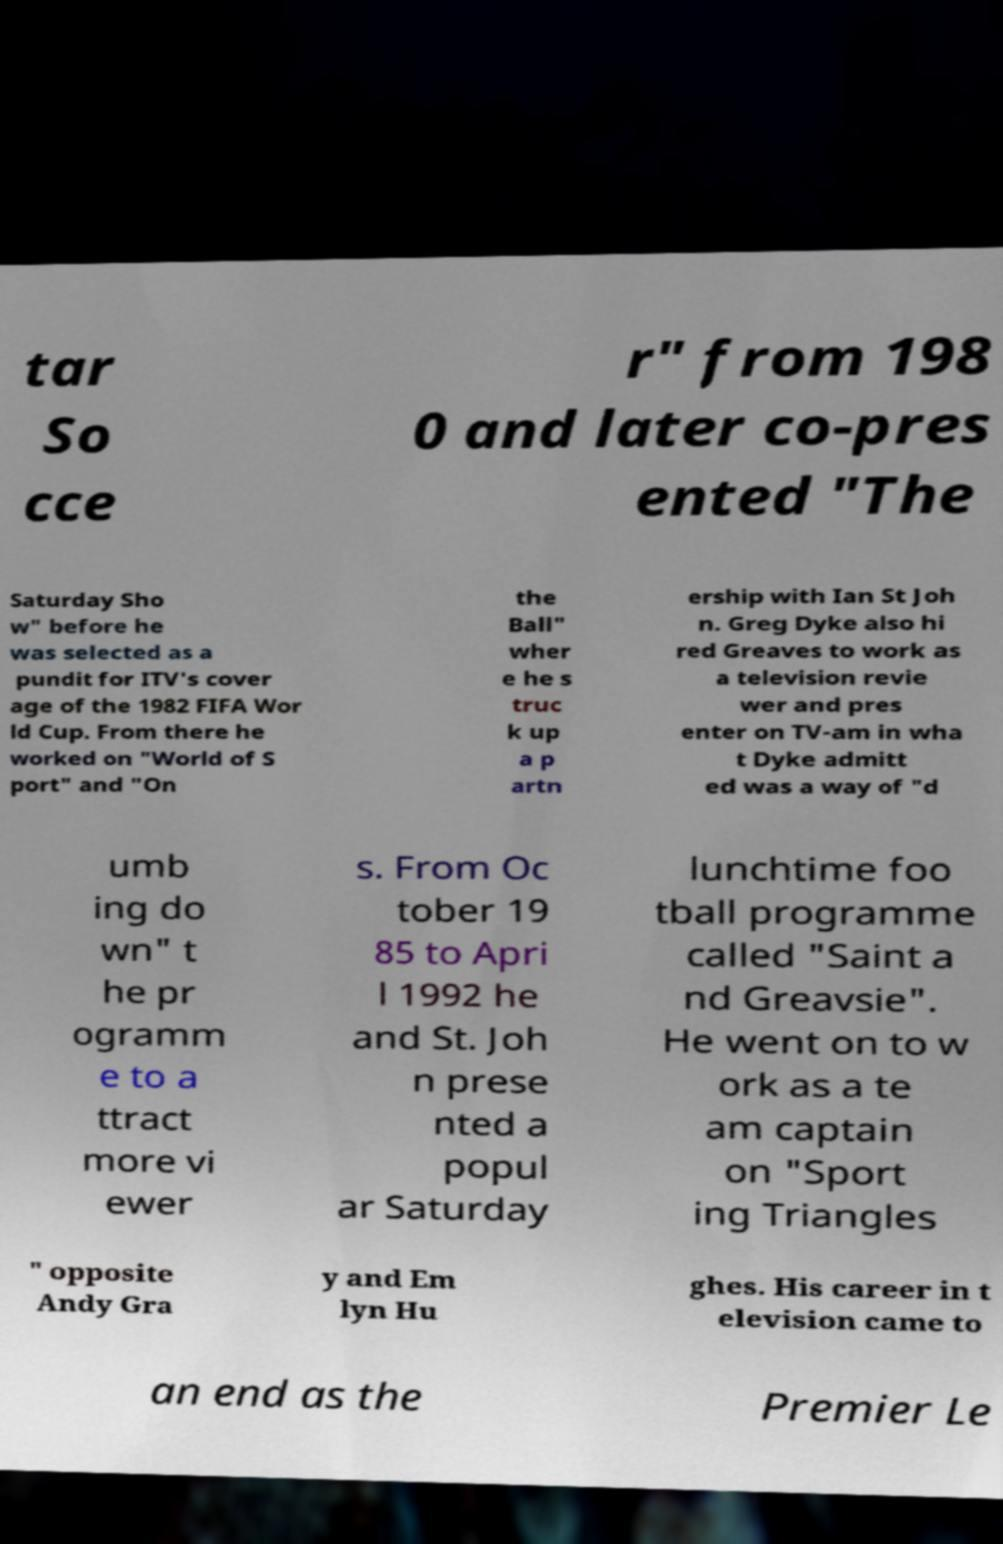Can you read and provide the text displayed in the image?This photo seems to have some interesting text. Can you extract and type it out for me? tar So cce r" from 198 0 and later co-pres ented "The Saturday Sho w" before he was selected as a pundit for ITV's cover age of the 1982 FIFA Wor ld Cup. From there he worked on "World of S port" and "On the Ball" wher e he s truc k up a p artn ership with Ian St Joh n. Greg Dyke also hi red Greaves to work as a television revie wer and pres enter on TV-am in wha t Dyke admitt ed was a way of "d umb ing do wn" t he pr ogramm e to a ttract more vi ewer s. From Oc tober 19 85 to Apri l 1992 he and St. Joh n prese nted a popul ar Saturday lunchtime foo tball programme called "Saint a nd Greavsie". He went on to w ork as a te am captain on "Sport ing Triangles " opposite Andy Gra y and Em lyn Hu ghes. His career in t elevision came to an end as the Premier Le 